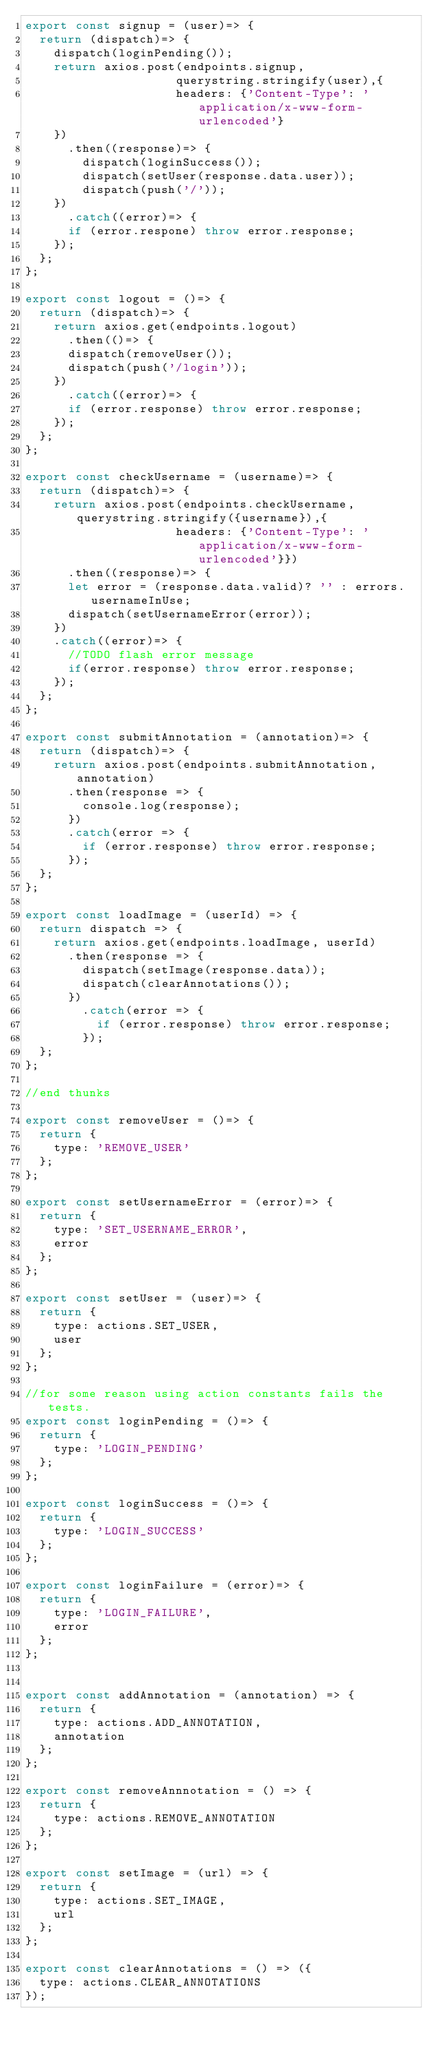Convert code to text. <code><loc_0><loc_0><loc_500><loc_500><_JavaScript_>export const signup = (user)=> {
  return (dispatch)=> {
    dispatch(loginPending());
    return axios.post(endpoints.signup,
                     querystring.stringify(user),{
                     headers: {'Content-Type': 'application/x-www-form-urlencoded'}
    })
      .then((response)=> {
        dispatch(loginSuccess());
        dispatch(setUser(response.data.user));
        dispatch(push('/'));
    })
      .catch((error)=> {
      if (error.respone) throw error.response;
    });
  };
};

export const logout = ()=> {
  return (dispatch)=> {
    return axios.get(endpoints.logout)
      .then(()=> {
      dispatch(removeUser());
      dispatch(push('/login'));
    })
      .catch((error)=> {
      if (error.response) throw error.response;
    });
  };
};

export const checkUsername = (username)=> {
  return (dispatch)=> {
    return axios.post(endpoints.checkUsername, querystring.stringify({username}),{
                     headers: {'Content-Type': 'application/x-www-form-urlencoded'}})
      .then((response)=> {
      let error = (response.data.valid)? '' : errors.usernameInUse;
      dispatch(setUsernameError(error));
    })
    .catch((error)=> {
      //TODO flash error message
      if(error.response) throw error.response;
    });
  };
};

export const submitAnnotation = (annotation)=> {
  return (dispatch)=> {
    return axios.post(endpoints.submitAnnotation, annotation)
      .then(response => {
        console.log(response);
      })
      .catch(error => {
        if (error.response) throw error.response;
      });
  };
};

export const loadImage = (userId) => {
  return dispatch => {
    return axios.get(endpoints.loadImage, userId)
      .then(response => {
        dispatch(setImage(response.data));
        dispatch(clearAnnotations());
      })
        .catch(error => {
          if (error.response) throw error.response;
        });
  };
};

//end thunks

export const removeUser = ()=> {
  return {
    type: 'REMOVE_USER'
  };
};

export const setUsernameError = (error)=> {
  return {
    type: 'SET_USERNAME_ERROR',
    error
  };
};

export const setUser = (user)=> {
  return {
    type: actions.SET_USER,
    user
  };
};

//for some reason using action constants fails the tests.
export const loginPending = ()=> {
  return {
    type: 'LOGIN_PENDING'
  };
};

export const loginSuccess = ()=> {
  return {
    type: 'LOGIN_SUCCESS'
  };
};

export const loginFailure = (error)=> {
  return {
    type: 'LOGIN_FAILURE',
    error
  };
};


export const addAnnotation = (annotation) => {
  return {
    type: actions.ADD_ANNOTATION,
    annotation
  };
};

export const removeAnnnotation = () => {
  return {
    type: actions.REMOVE_ANNOTATION
  };
};

export const setImage = (url) => {
  return {
    type: actions.SET_IMAGE,
    url
  };
};

export const clearAnnotations = () => ({
  type: actions.CLEAR_ANNOTATIONS
});</code> 